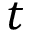<formula> <loc_0><loc_0><loc_500><loc_500>t</formula> 